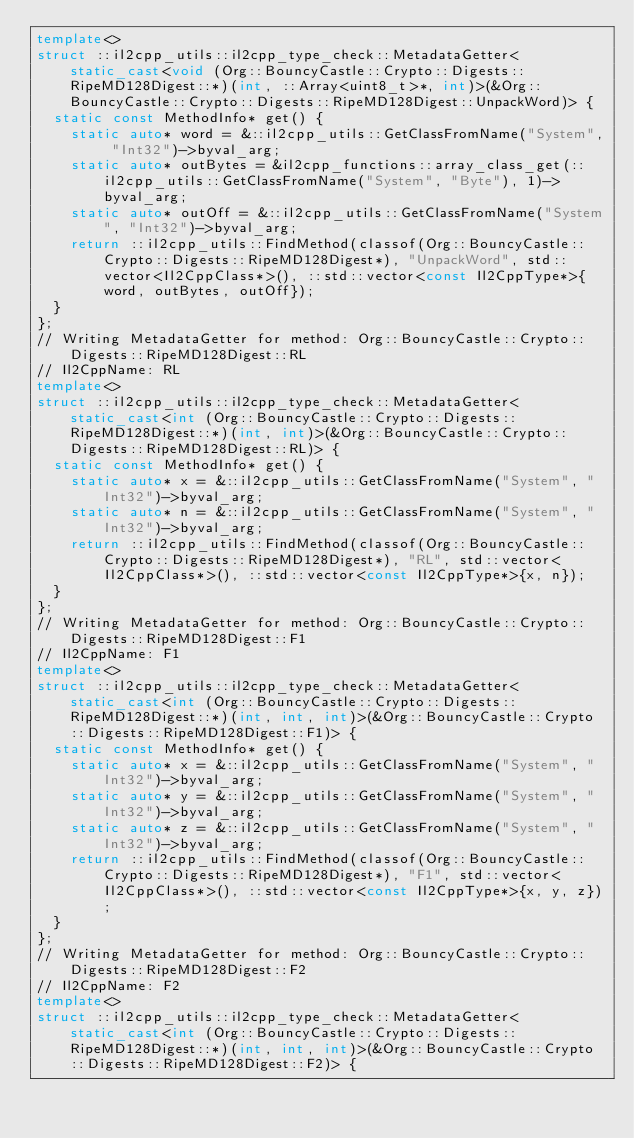<code> <loc_0><loc_0><loc_500><loc_500><_C++_>template<>
struct ::il2cpp_utils::il2cpp_type_check::MetadataGetter<static_cast<void (Org::BouncyCastle::Crypto::Digests::RipeMD128Digest::*)(int, ::Array<uint8_t>*, int)>(&Org::BouncyCastle::Crypto::Digests::RipeMD128Digest::UnpackWord)> {
  static const MethodInfo* get() {
    static auto* word = &::il2cpp_utils::GetClassFromName("System", "Int32")->byval_arg;
    static auto* outBytes = &il2cpp_functions::array_class_get(::il2cpp_utils::GetClassFromName("System", "Byte"), 1)->byval_arg;
    static auto* outOff = &::il2cpp_utils::GetClassFromName("System", "Int32")->byval_arg;
    return ::il2cpp_utils::FindMethod(classof(Org::BouncyCastle::Crypto::Digests::RipeMD128Digest*), "UnpackWord", std::vector<Il2CppClass*>(), ::std::vector<const Il2CppType*>{word, outBytes, outOff});
  }
};
// Writing MetadataGetter for method: Org::BouncyCastle::Crypto::Digests::RipeMD128Digest::RL
// Il2CppName: RL
template<>
struct ::il2cpp_utils::il2cpp_type_check::MetadataGetter<static_cast<int (Org::BouncyCastle::Crypto::Digests::RipeMD128Digest::*)(int, int)>(&Org::BouncyCastle::Crypto::Digests::RipeMD128Digest::RL)> {
  static const MethodInfo* get() {
    static auto* x = &::il2cpp_utils::GetClassFromName("System", "Int32")->byval_arg;
    static auto* n = &::il2cpp_utils::GetClassFromName("System", "Int32")->byval_arg;
    return ::il2cpp_utils::FindMethod(classof(Org::BouncyCastle::Crypto::Digests::RipeMD128Digest*), "RL", std::vector<Il2CppClass*>(), ::std::vector<const Il2CppType*>{x, n});
  }
};
// Writing MetadataGetter for method: Org::BouncyCastle::Crypto::Digests::RipeMD128Digest::F1
// Il2CppName: F1
template<>
struct ::il2cpp_utils::il2cpp_type_check::MetadataGetter<static_cast<int (Org::BouncyCastle::Crypto::Digests::RipeMD128Digest::*)(int, int, int)>(&Org::BouncyCastle::Crypto::Digests::RipeMD128Digest::F1)> {
  static const MethodInfo* get() {
    static auto* x = &::il2cpp_utils::GetClassFromName("System", "Int32")->byval_arg;
    static auto* y = &::il2cpp_utils::GetClassFromName("System", "Int32")->byval_arg;
    static auto* z = &::il2cpp_utils::GetClassFromName("System", "Int32")->byval_arg;
    return ::il2cpp_utils::FindMethod(classof(Org::BouncyCastle::Crypto::Digests::RipeMD128Digest*), "F1", std::vector<Il2CppClass*>(), ::std::vector<const Il2CppType*>{x, y, z});
  }
};
// Writing MetadataGetter for method: Org::BouncyCastle::Crypto::Digests::RipeMD128Digest::F2
// Il2CppName: F2
template<>
struct ::il2cpp_utils::il2cpp_type_check::MetadataGetter<static_cast<int (Org::BouncyCastle::Crypto::Digests::RipeMD128Digest::*)(int, int, int)>(&Org::BouncyCastle::Crypto::Digests::RipeMD128Digest::F2)> {</code> 